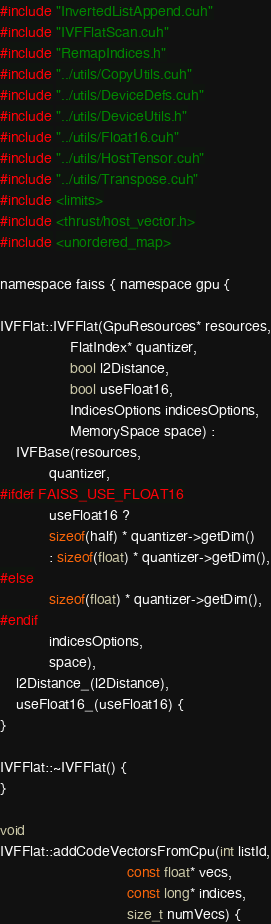<code> <loc_0><loc_0><loc_500><loc_500><_Cuda_>#include "InvertedListAppend.cuh"
#include "IVFFlatScan.cuh"
#include "RemapIndices.h"
#include "../utils/CopyUtils.cuh"
#include "../utils/DeviceDefs.cuh"
#include "../utils/DeviceUtils.h"
#include "../utils/Float16.cuh"
#include "../utils/HostTensor.cuh"
#include "../utils/Transpose.cuh"
#include <limits>
#include <thrust/host_vector.h>
#include <unordered_map>

namespace faiss { namespace gpu {

IVFFlat::IVFFlat(GpuResources* resources,
                 FlatIndex* quantizer,
                 bool l2Distance,
                 bool useFloat16,
                 IndicesOptions indicesOptions,
                 MemorySpace space) :
    IVFBase(resources,
            quantizer,
#ifdef FAISS_USE_FLOAT16
            useFloat16 ?
            sizeof(half) * quantizer->getDim()
            : sizeof(float) * quantizer->getDim(),
#else
            sizeof(float) * quantizer->getDim(),
#endif
            indicesOptions,
            space),
    l2Distance_(l2Distance),
    useFloat16_(useFloat16) {
}

IVFFlat::~IVFFlat() {
}

void
IVFFlat::addCodeVectorsFromCpu(int listId,
                               const float* vecs,
                               const long* indices,
                               size_t numVecs) {</code> 